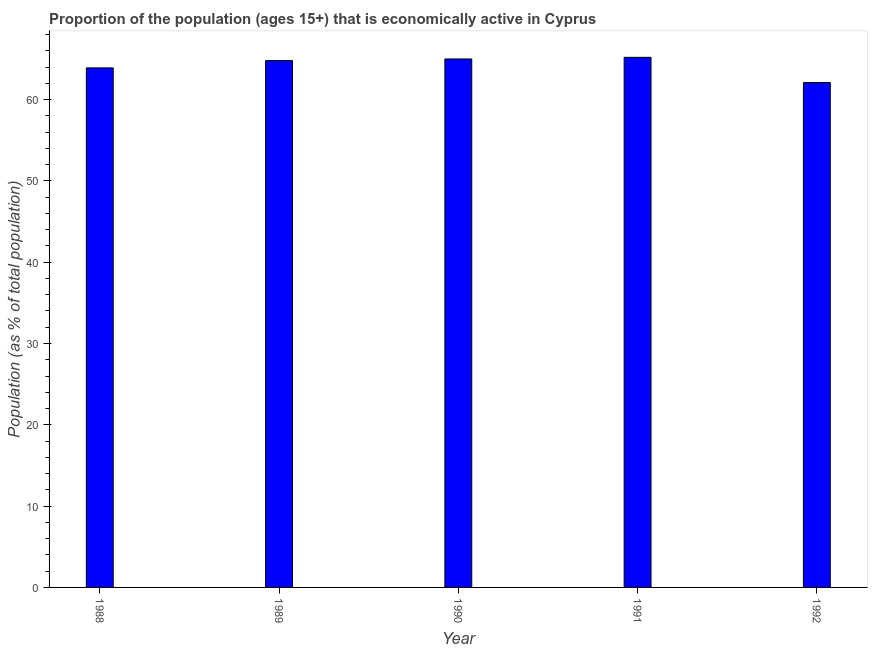Does the graph contain grids?
Your answer should be very brief. No. What is the title of the graph?
Provide a succinct answer. Proportion of the population (ages 15+) that is economically active in Cyprus. What is the label or title of the X-axis?
Ensure brevity in your answer.  Year. What is the label or title of the Y-axis?
Your answer should be compact. Population (as % of total population). What is the percentage of economically active population in 1990?
Give a very brief answer. 65. Across all years, what is the maximum percentage of economically active population?
Make the answer very short. 65.2. Across all years, what is the minimum percentage of economically active population?
Offer a terse response. 62.1. In which year was the percentage of economically active population maximum?
Keep it short and to the point. 1991. In which year was the percentage of economically active population minimum?
Provide a succinct answer. 1992. What is the sum of the percentage of economically active population?
Offer a terse response. 321. What is the difference between the percentage of economically active population in 1988 and 1990?
Offer a terse response. -1.1. What is the average percentage of economically active population per year?
Keep it short and to the point. 64.2. What is the median percentage of economically active population?
Offer a terse response. 64.8. In how many years, is the percentage of economically active population greater than 16 %?
Provide a succinct answer. 5. Do a majority of the years between 1992 and 1988 (inclusive) have percentage of economically active population greater than 34 %?
Make the answer very short. Yes. What is the ratio of the percentage of economically active population in 1989 to that in 1992?
Make the answer very short. 1.04. Is the difference between the percentage of economically active population in 1988 and 1990 greater than the difference between any two years?
Keep it short and to the point. No. What is the difference between the highest and the second highest percentage of economically active population?
Your answer should be compact. 0.2. In how many years, is the percentage of economically active population greater than the average percentage of economically active population taken over all years?
Your response must be concise. 3. Are all the bars in the graph horizontal?
Your answer should be compact. No. What is the difference between two consecutive major ticks on the Y-axis?
Ensure brevity in your answer.  10. What is the Population (as % of total population) in 1988?
Provide a short and direct response. 63.9. What is the Population (as % of total population) of 1989?
Ensure brevity in your answer.  64.8. What is the Population (as % of total population) of 1990?
Ensure brevity in your answer.  65. What is the Population (as % of total population) in 1991?
Make the answer very short. 65.2. What is the Population (as % of total population) of 1992?
Provide a succinct answer. 62.1. What is the difference between the Population (as % of total population) in 1988 and 1989?
Provide a succinct answer. -0.9. What is the difference between the Population (as % of total population) in 1988 and 1990?
Ensure brevity in your answer.  -1.1. What is the difference between the Population (as % of total population) in 1988 and 1991?
Make the answer very short. -1.3. What is the difference between the Population (as % of total population) in 1989 and 1991?
Give a very brief answer. -0.4. What is the difference between the Population (as % of total population) in 1989 and 1992?
Offer a terse response. 2.7. What is the difference between the Population (as % of total population) in 1990 and 1992?
Give a very brief answer. 2.9. What is the ratio of the Population (as % of total population) in 1988 to that in 1990?
Give a very brief answer. 0.98. What is the ratio of the Population (as % of total population) in 1988 to that in 1991?
Your response must be concise. 0.98. What is the ratio of the Population (as % of total population) in 1989 to that in 1991?
Your answer should be very brief. 0.99. What is the ratio of the Population (as % of total population) in 1989 to that in 1992?
Provide a short and direct response. 1.04. What is the ratio of the Population (as % of total population) in 1990 to that in 1991?
Provide a succinct answer. 1. What is the ratio of the Population (as % of total population) in 1990 to that in 1992?
Your answer should be compact. 1.05. What is the ratio of the Population (as % of total population) in 1991 to that in 1992?
Keep it short and to the point. 1.05. 